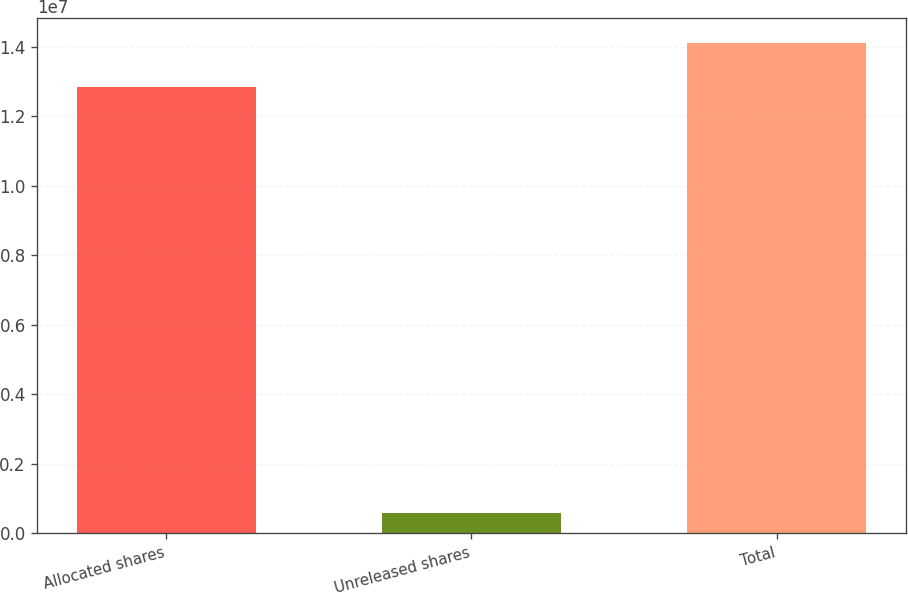<chart> <loc_0><loc_0><loc_500><loc_500><bar_chart><fcel>Allocated shares<fcel>Unreleased shares<fcel>Total<nl><fcel>1.28237e+07<fcel>576645<fcel>1.41061e+07<nl></chart> 